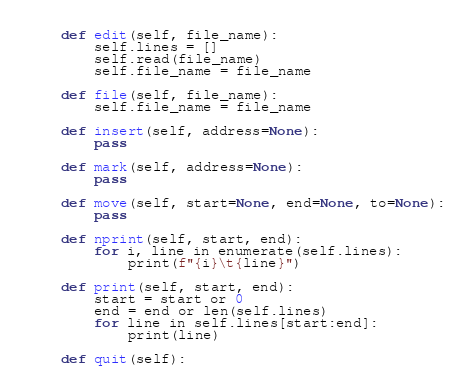<code> <loc_0><loc_0><loc_500><loc_500><_Python_>
    def edit(self, file_name):
        self.lines = []
        self.read(file_name)
        self.file_name = file_name

    def file(self, file_name):
        self.file_name = file_name

    def insert(self, address=None):
        pass

    def mark(self, address=None):
        pass

    def move(self, start=None, end=None, to=None):
        pass

    def nprint(self, start, end):
        for i, line in enumerate(self.lines):
            print(f"{i}\t{line}")

    def print(self, start, end):
        start = start or 0
        end = end or len(self.lines)
        for line in self.lines[start:end]:
            print(line)

    def quit(self):</code> 